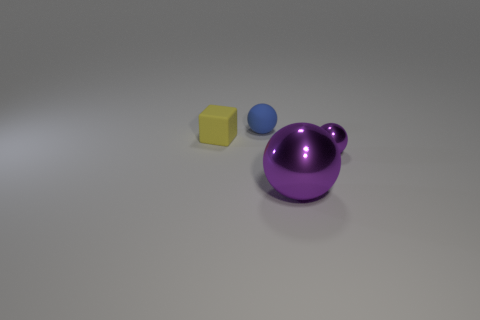Add 1 big cyan metallic spheres. How many objects exist? 5 Subtract all cubes. How many objects are left? 3 Add 4 purple objects. How many purple objects are left? 6 Add 1 big purple shiny things. How many big purple shiny things exist? 2 Subtract 0 gray cubes. How many objects are left? 4 Subtract all big purple objects. Subtract all metallic spheres. How many objects are left? 1 